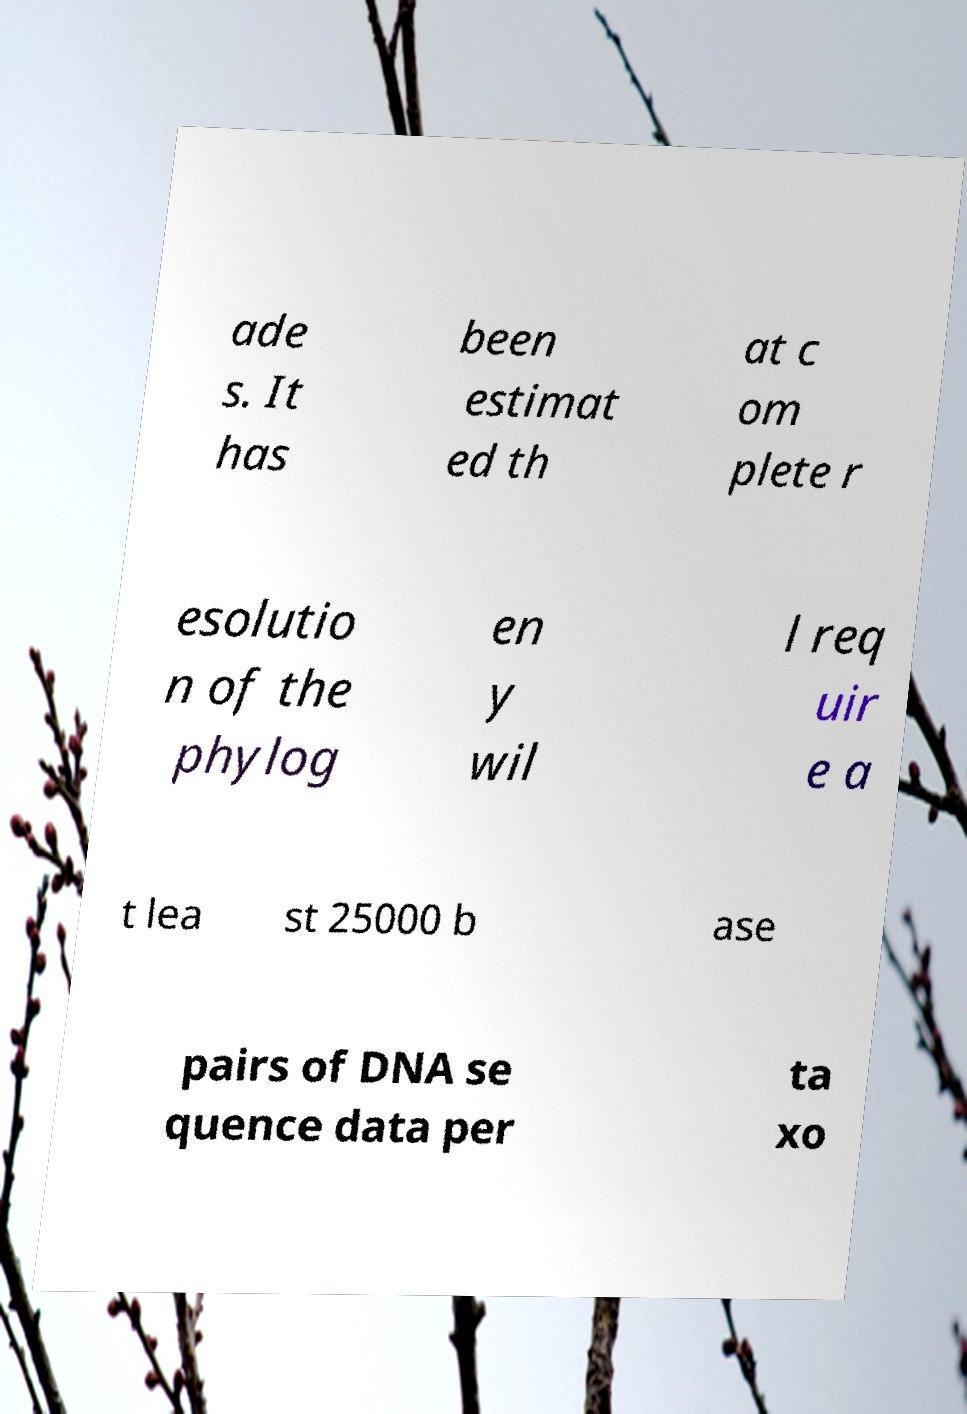For documentation purposes, I need the text within this image transcribed. Could you provide that? ade s. It has been estimat ed th at c om plete r esolutio n of the phylog en y wil l req uir e a t lea st 25000 b ase pairs of DNA se quence data per ta xo 